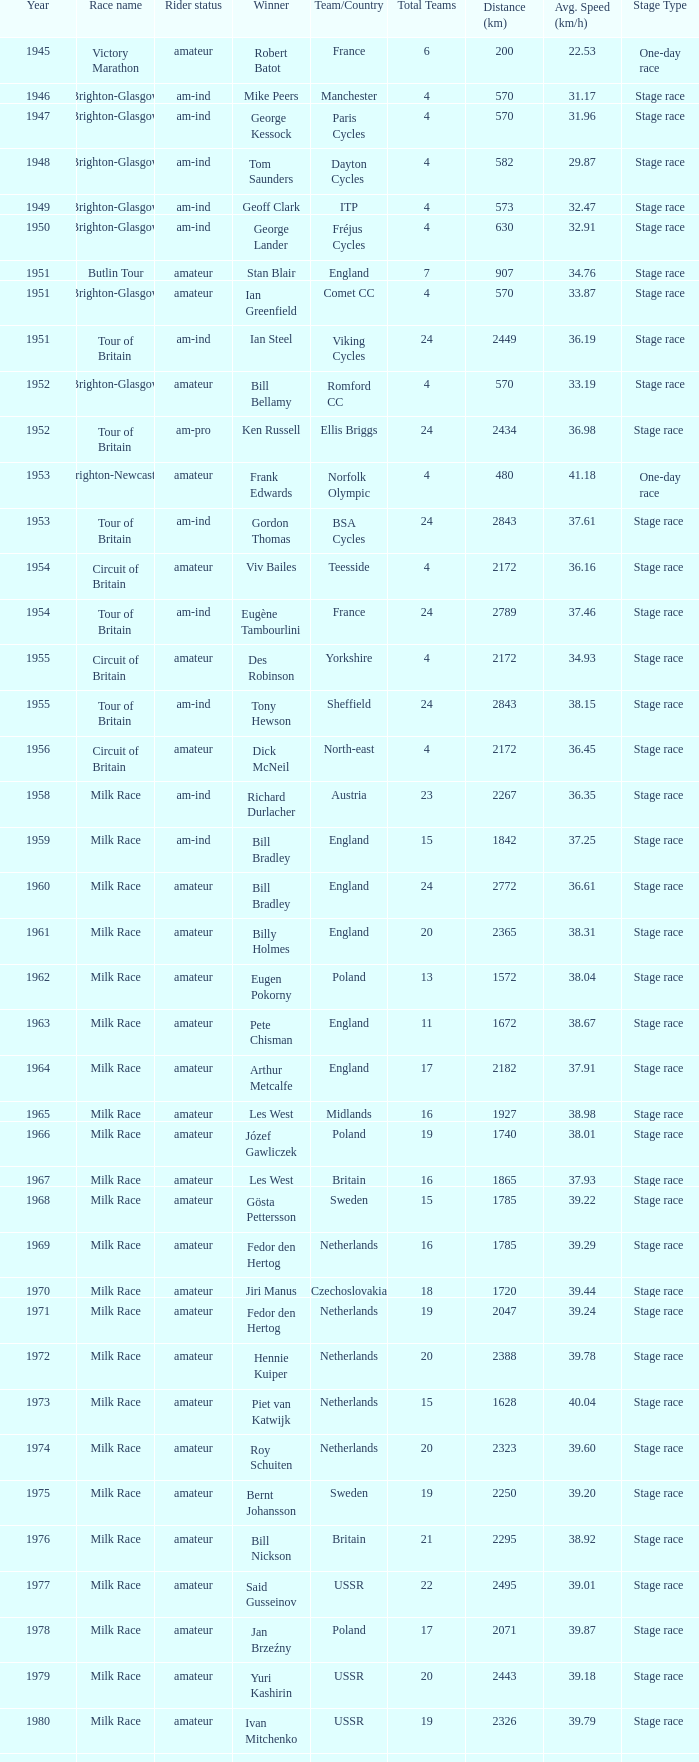What ream played later than 1958 in the kellogg's tour? ANC, Fagor, Z-Peugeot, Weinnmann-SMM, Motorola, Motorola, Motorola, Lampre. 